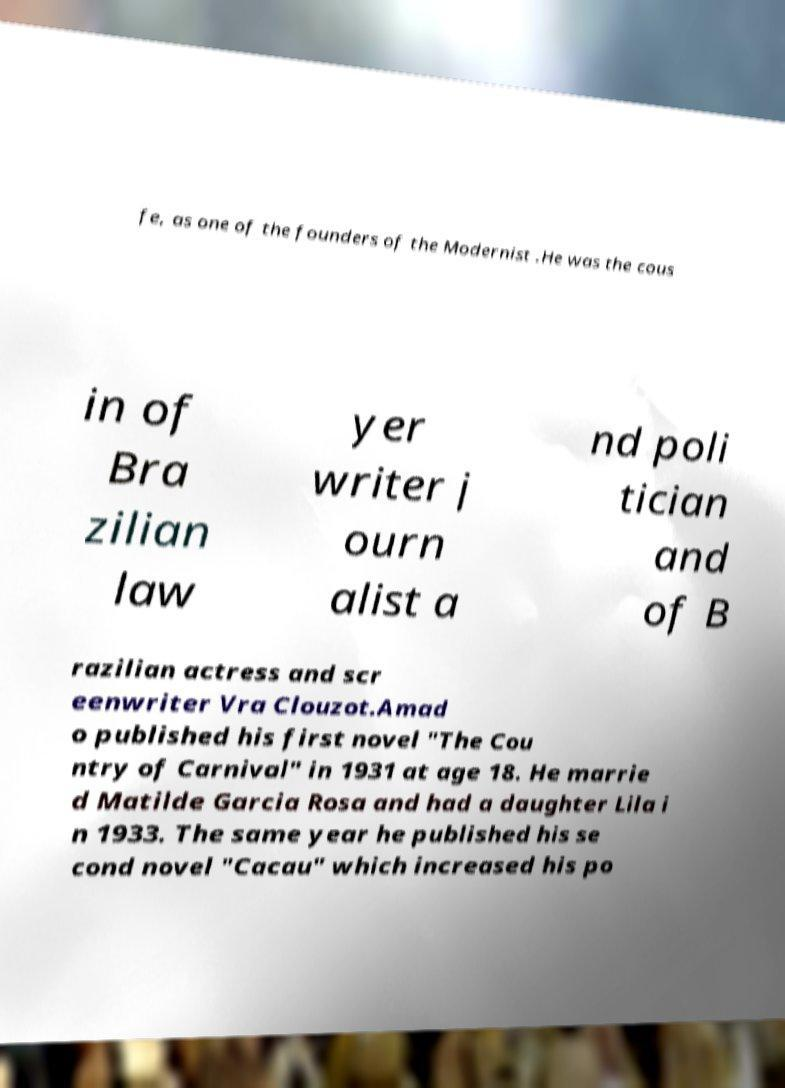For documentation purposes, I need the text within this image transcribed. Could you provide that? fe, as one of the founders of the Modernist .He was the cous in of Bra zilian law yer writer j ourn alist a nd poli tician and of B razilian actress and scr eenwriter Vra Clouzot.Amad o published his first novel "The Cou ntry of Carnival" in 1931 at age 18. He marrie d Matilde Garcia Rosa and had a daughter Lila i n 1933. The same year he published his se cond novel "Cacau" which increased his po 